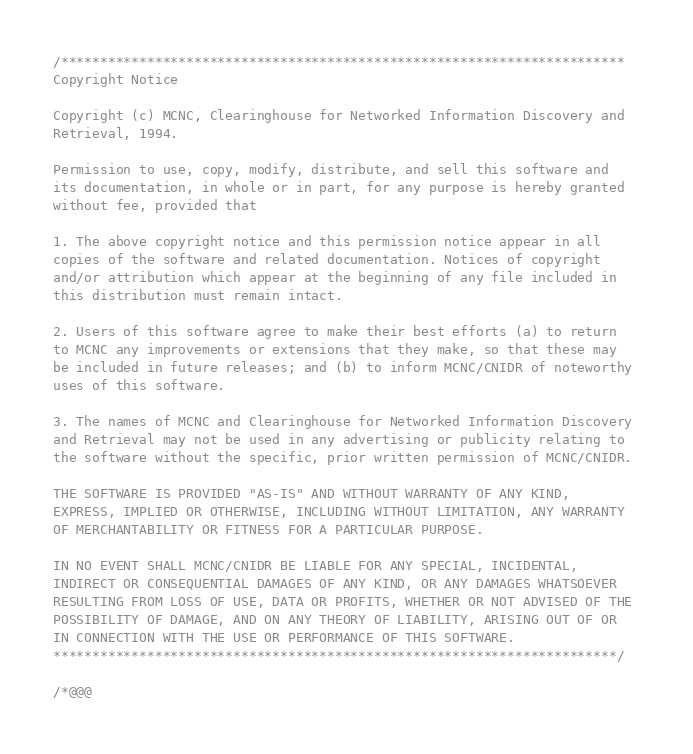<code> <loc_0><loc_0><loc_500><loc_500><_C_>/************************************************************************
Copyright Notice

Copyright (c) MCNC, Clearinghouse for Networked Information Discovery and
Retrieval, 1994. 

Permission to use, copy, modify, distribute, and sell this software and
its documentation, in whole or in part, for any purpose is hereby granted
without fee, provided that

1. The above copyright notice and this permission notice appear in all
copies of the software and related documentation. Notices of copyright
and/or attribution which appear at the beginning of any file included in
this distribution must remain intact. 

2. Users of this software agree to make their best efforts (a) to return
to MCNC any improvements or extensions that they make, so that these may
be included in future releases; and (b) to inform MCNC/CNIDR of noteworthy
uses of this software. 

3. The names of MCNC and Clearinghouse for Networked Information Discovery
and Retrieval may not be used in any advertising or publicity relating to
the software without the specific, prior written permission of MCNC/CNIDR. 

THE SOFTWARE IS PROVIDED "AS-IS" AND WITHOUT WARRANTY OF ANY KIND,
EXPRESS, IMPLIED OR OTHERWISE, INCLUDING WITHOUT LIMITATION, ANY WARRANTY
OF MERCHANTABILITY OR FITNESS FOR A PARTICULAR PURPOSE. 

IN NO EVENT SHALL MCNC/CNIDR BE LIABLE FOR ANY SPECIAL, INCIDENTAL,
INDIRECT OR CONSEQUENTIAL DAMAGES OF ANY KIND, OR ANY DAMAGES WHATSOEVER
RESULTING FROM LOSS OF USE, DATA OR PROFITS, WHETHER OR NOT ADVISED OF THE
POSSIBILITY OF DAMAGE, AND ON ANY THEORY OF LIABILITY, ARISING OUT OF OR
IN CONNECTION WITH THE USE OR PERFORMANCE OF THIS SOFTWARE. 
************************************************************************/

/*@@@</code> 